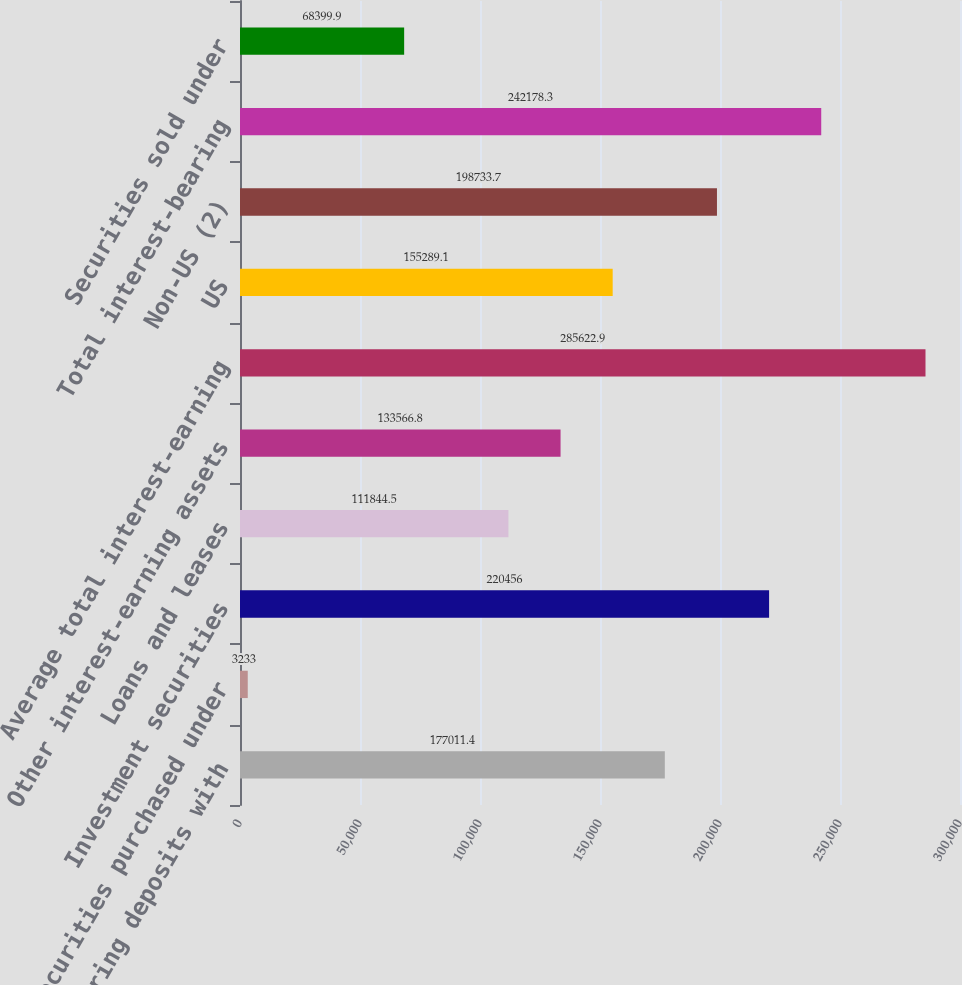Convert chart. <chart><loc_0><loc_0><loc_500><loc_500><bar_chart><fcel>Interest-bearing deposits with<fcel>Securities purchased under<fcel>Investment securities<fcel>Loans and leases<fcel>Other interest-earning assets<fcel>Average total interest-earning<fcel>US<fcel>Non-US (2)<fcel>Total interest-bearing<fcel>Securities sold under<nl><fcel>177011<fcel>3233<fcel>220456<fcel>111844<fcel>133567<fcel>285623<fcel>155289<fcel>198734<fcel>242178<fcel>68399.9<nl></chart> 